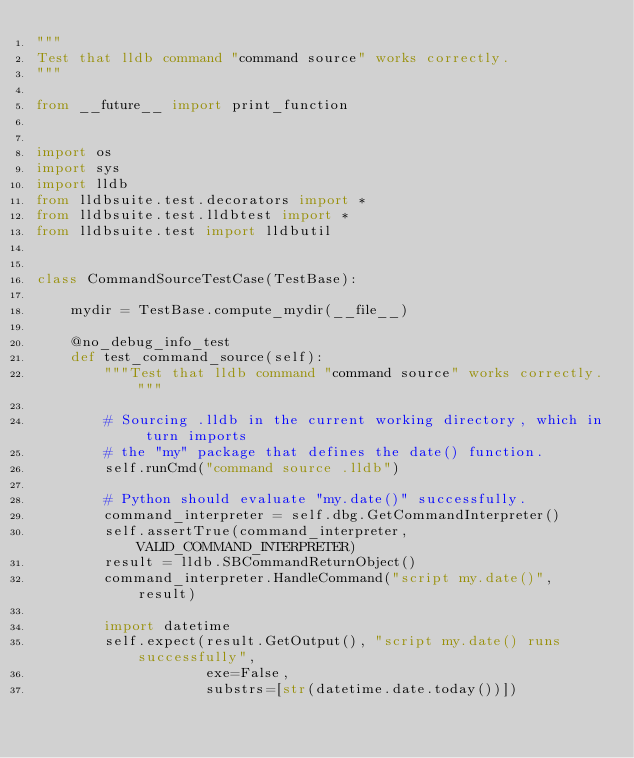<code> <loc_0><loc_0><loc_500><loc_500><_Python_>"""
Test that lldb command "command source" works correctly.
"""

from __future__ import print_function


import os
import sys
import lldb
from lldbsuite.test.decorators import *
from lldbsuite.test.lldbtest import *
from lldbsuite.test import lldbutil


class CommandSourceTestCase(TestBase):

    mydir = TestBase.compute_mydir(__file__)

    @no_debug_info_test
    def test_command_source(self):
        """Test that lldb command "command source" works correctly."""

        # Sourcing .lldb in the current working directory, which in turn imports
        # the "my" package that defines the date() function.
        self.runCmd("command source .lldb")

        # Python should evaluate "my.date()" successfully.
        command_interpreter = self.dbg.GetCommandInterpreter()
        self.assertTrue(command_interpreter, VALID_COMMAND_INTERPRETER)
        result = lldb.SBCommandReturnObject()
        command_interpreter.HandleCommand("script my.date()", result)

        import datetime
        self.expect(result.GetOutput(), "script my.date() runs successfully",
                    exe=False,
                    substrs=[str(datetime.date.today())])
</code> 